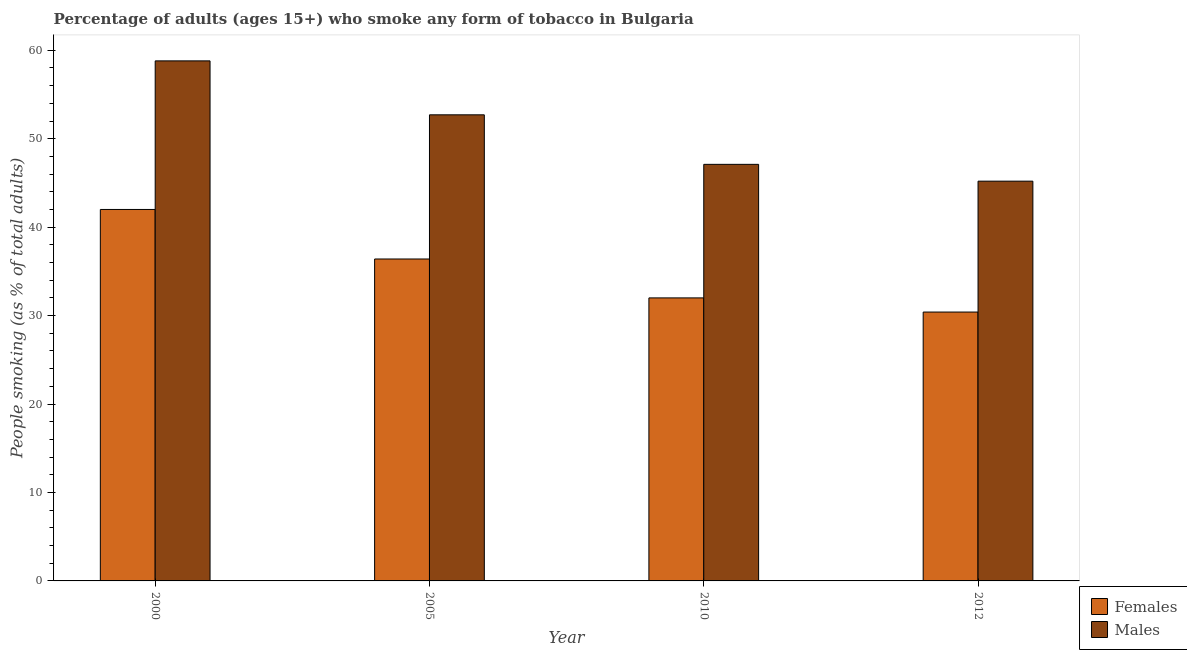How many groups of bars are there?
Ensure brevity in your answer.  4. Are the number of bars per tick equal to the number of legend labels?
Keep it short and to the point. Yes. Are the number of bars on each tick of the X-axis equal?
Provide a short and direct response. Yes. How many bars are there on the 3rd tick from the right?
Make the answer very short. 2. What is the label of the 3rd group of bars from the left?
Provide a succinct answer. 2010. In how many cases, is the number of bars for a given year not equal to the number of legend labels?
Keep it short and to the point. 0. What is the percentage of males who smoke in 2012?
Make the answer very short. 45.2. Across all years, what is the maximum percentage of males who smoke?
Offer a terse response. 58.8. Across all years, what is the minimum percentage of males who smoke?
Your answer should be compact. 45.2. What is the total percentage of males who smoke in the graph?
Ensure brevity in your answer.  203.8. What is the difference between the percentage of females who smoke in 2005 and that in 2012?
Offer a terse response. 6. What is the difference between the percentage of males who smoke in 2005 and the percentage of females who smoke in 2010?
Keep it short and to the point. 5.6. What is the average percentage of females who smoke per year?
Offer a very short reply. 35.2. In the year 2000, what is the difference between the percentage of males who smoke and percentage of females who smoke?
Make the answer very short. 0. What is the ratio of the percentage of males who smoke in 2000 to that in 2010?
Provide a short and direct response. 1.25. What is the difference between the highest and the second highest percentage of females who smoke?
Provide a succinct answer. 5.6. What is the difference between the highest and the lowest percentage of females who smoke?
Offer a terse response. 11.6. What does the 2nd bar from the left in 2012 represents?
Give a very brief answer. Males. What does the 1st bar from the right in 2000 represents?
Ensure brevity in your answer.  Males. How many years are there in the graph?
Your answer should be compact. 4. Does the graph contain grids?
Your answer should be very brief. No. How many legend labels are there?
Make the answer very short. 2. How are the legend labels stacked?
Your response must be concise. Vertical. What is the title of the graph?
Keep it short and to the point. Percentage of adults (ages 15+) who smoke any form of tobacco in Bulgaria. What is the label or title of the X-axis?
Provide a succinct answer. Year. What is the label or title of the Y-axis?
Give a very brief answer. People smoking (as % of total adults). What is the People smoking (as % of total adults) in Females in 2000?
Your response must be concise. 42. What is the People smoking (as % of total adults) of Males in 2000?
Your response must be concise. 58.8. What is the People smoking (as % of total adults) in Females in 2005?
Keep it short and to the point. 36.4. What is the People smoking (as % of total adults) of Males in 2005?
Offer a very short reply. 52.7. What is the People smoking (as % of total adults) in Females in 2010?
Offer a terse response. 32. What is the People smoking (as % of total adults) in Males in 2010?
Give a very brief answer. 47.1. What is the People smoking (as % of total adults) of Females in 2012?
Provide a short and direct response. 30.4. What is the People smoking (as % of total adults) of Males in 2012?
Your answer should be very brief. 45.2. Across all years, what is the maximum People smoking (as % of total adults) of Males?
Offer a terse response. 58.8. Across all years, what is the minimum People smoking (as % of total adults) of Females?
Your answer should be very brief. 30.4. Across all years, what is the minimum People smoking (as % of total adults) in Males?
Ensure brevity in your answer.  45.2. What is the total People smoking (as % of total adults) of Females in the graph?
Ensure brevity in your answer.  140.8. What is the total People smoking (as % of total adults) of Males in the graph?
Keep it short and to the point. 203.8. What is the difference between the People smoking (as % of total adults) in Males in 2000 and that in 2005?
Give a very brief answer. 6.1. What is the difference between the People smoking (as % of total adults) in Males in 2000 and that in 2010?
Your answer should be very brief. 11.7. What is the difference between the People smoking (as % of total adults) in Females in 2000 and that in 2012?
Provide a succinct answer. 11.6. What is the difference between the People smoking (as % of total adults) in Males in 2000 and that in 2012?
Your answer should be very brief. 13.6. What is the difference between the People smoking (as % of total adults) in Females in 2000 and the People smoking (as % of total adults) in Males in 2005?
Give a very brief answer. -10.7. What is the difference between the People smoking (as % of total adults) in Females in 2005 and the People smoking (as % of total adults) in Males in 2012?
Provide a succinct answer. -8.8. What is the average People smoking (as % of total adults) of Females per year?
Your answer should be compact. 35.2. What is the average People smoking (as % of total adults) in Males per year?
Offer a very short reply. 50.95. In the year 2000, what is the difference between the People smoking (as % of total adults) of Females and People smoking (as % of total adults) of Males?
Give a very brief answer. -16.8. In the year 2005, what is the difference between the People smoking (as % of total adults) of Females and People smoking (as % of total adults) of Males?
Your response must be concise. -16.3. In the year 2010, what is the difference between the People smoking (as % of total adults) of Females and People smoking (as % of total adults) of Males?
Provide a short and direct response. -15.1. In the year 2012, what is the difference between the People smoking (as % of total adults) of Females and People smoking (as % of total adults) of Males?
Offer a terse response. -14.8. What is the ratio of the People smoking (as % of total adults) of Females in 2000 to that in 2005?
Offer a terse response. 1.15. What is the ratio of the People smoking (as % of total adults) of Males in 2000 to that in 2005?
Make the answer very short. 1.12. What is the ratio of the People smoking (as % of total adults) in Females in 2000 to that in 2010?
Offer a terse response. 1.31. What is the ratio of the People smoking (as % of total adults) in Males in 2000 to that in 2010?
Provide a short and direct response. 1.25. What is the ratio of the People smoking (as % of total adults) of Females in 2000 to that in 2012?
Make the answer very short. 1.38. What is the ratio of the People smoking (as % of total adults) in Males in 2000 to that in 2012?
Provide a short and direct response. 1.3. What is the ratio of the People smoking (as % of total adults) in Females in 2005 to that in 2010?
Your response must be concise. 1.14. What is the ratio of the People smoking (as % of total adults) of Males in 2005 to that in 2010?
Offer a very short reply. 1.12. What is the ratio of the People smoking (as % of total adults) in Females in 2005 to that in 2012?
Keep it short and to the point. 1.2. What is the ratio of the People smoking (as % of total adults) of Males in 2005 to that in 2012?
Your response must be concise. 1.17. What is the ratio of the People smoking (as % of total adults) in Females in 2010 to that in 2012?
Give a very brief answer. 1.05. What is the ratio of the People smoking (as % of total adults) of Males in 2010 to that in 2012?
Ensure brevity in your answer.  1.04. What is the difference between the highest and the second highest People smoking (as % of total adults) in Females?
Your answer should be compact. 5.6. What is the difference between the highest and the second highest People smoking (as % of total adults) of Males?
Keep it short and to the point. 6.1. What is the difference between the highest and the lowest People smoking (as % of total adults) in Females?
Your answer should be very brief. 11.6. 